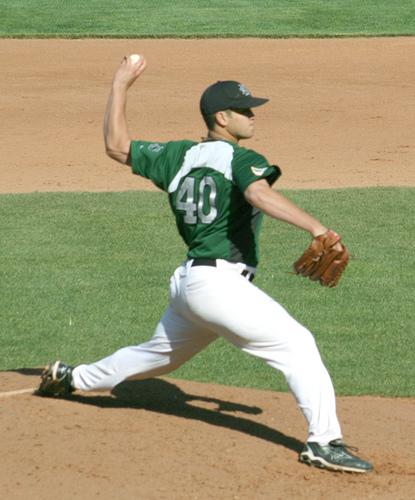What color is the man's pants?
Answer briefly. White. What color is the hat?
Quick response, please. Green. What is the man holding?
Short answer required. Baseball. What team is playing?
Quick response, please. Green team. How many different colors are on the man's uniform?
Write a very short answer. 2. What is the number on his shirt?
Quick response, please. 40. 